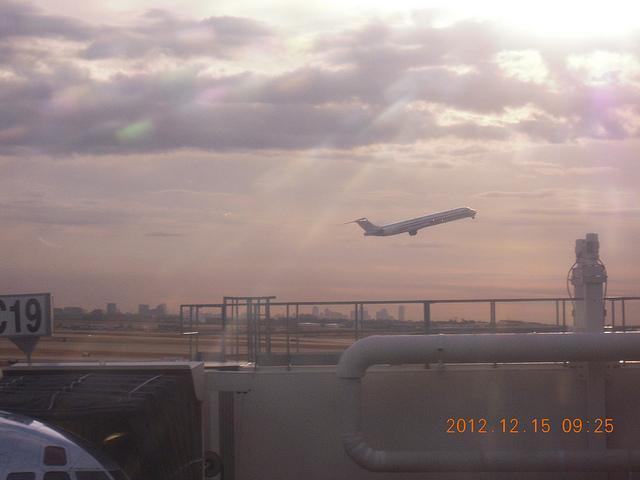How many people are there?
Give a very brief answer. 0. 